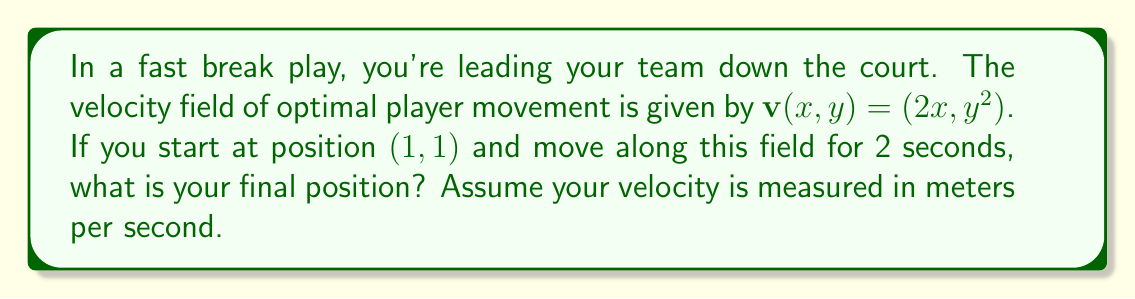What is the answer to this math problem? Let's approach this step-by-step:

1) The velocity field is given by $\mathbf{v}(x,y) = (2x, y^2)$. This means that at any point $(x,y)$, the velocity vector is $(2x, y^2)$.

2) To find the position at any time $t$, we need to solve the system of differential equations:

   $$\frac{dx}{dt} = 2x$$
   $$\frac{dy}{dt} = y^2$$

3) For the x-coordinate:
   $$\frac{dx}{dt} = 2x$$
   $$\int \frac{dx}{x} = \int 2dt$$
   $$\ln|x| = 2t + C$$
   $$x = e^{2t + C} = Ae^{2t}$$
   
   Given $x(0) = 1$, we can find $A = 1$. So $x(t) = e^{2t}$.

4) For the y-coordinate:
   $$\frac{dy}{dt} = y^2$$
   $$\int \frac{dy}{y^2} = \int dt$$
   $$-\frac{1}{y} = t + C$$
   $$y = -\frac{1}{t + C} = \frac{1}{B - t}$$
   
   Given $y(0) = 1$, we can find $B = 1$. So $y(t) = \frac{1}{1 - t}$.

5) After 2 seconds, the position is:
   $$x(2) = e^{2(2)} = e^4$$
   $$y(2) = \frac{1}{1 - 2} = -1$$

Therefore, the final position after 2 seconds is $(e^4, -1)$.
Answer: $(e^4, -1)$ 